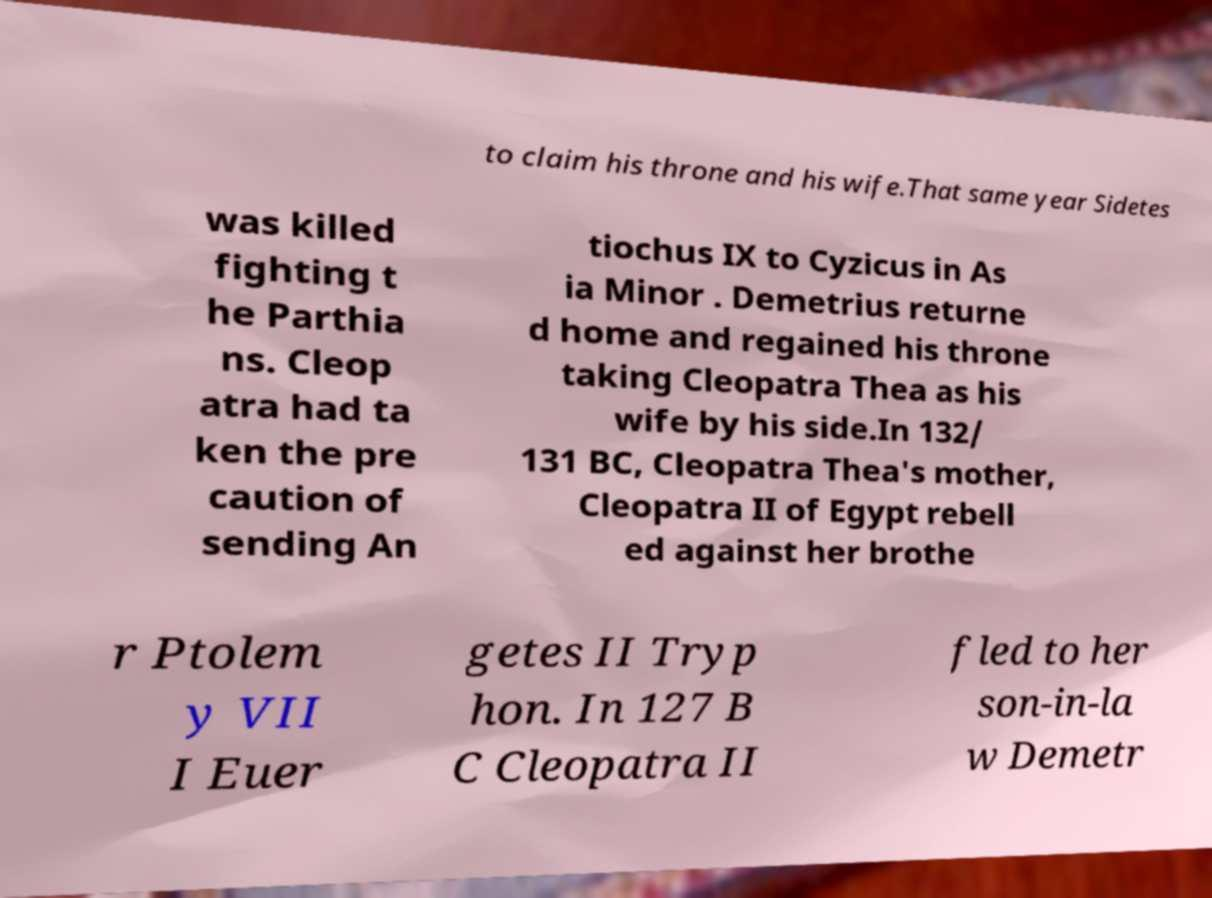What messages or text are displayed in this image? I need them in a readable, typed format. to claim his throne and his wife.That same year Sidetes was killed fighting t he Parthia ns. Cleop atra had ta ken the pre caution of sending An tiochus IX to Cyzicus in As ia Minor . Demetrius returne d home and regained his throne taking Cleopatra Thea as his wife by his side.In 132/ 131 BC, Cleopatra Thea's mother, Cleopatra II of Egypt rebell ed against her brothe r Ptolem y VII I Euer getes II Tryp hon. In 127 B C Cleopatra II fled to her son-in-la w Demetr 